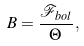<formula> <loc_0><loc_0><loc_500><loc_500>B = \frac { \mathcal { F } _ { b o l } } { \Theta } \, ,</formula> 